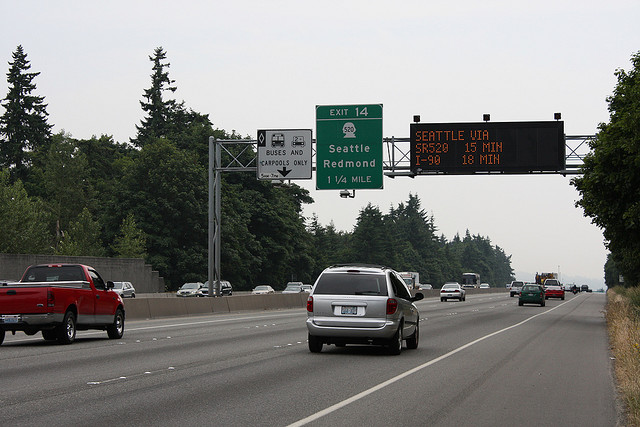Extract all visible text content from this image. EXIT 14 Seattle Redmond MILE SR529 I 90 18 MIH 15 MIH VIA SEATTLE 1/4 1 520 ONLY AND BUSES 